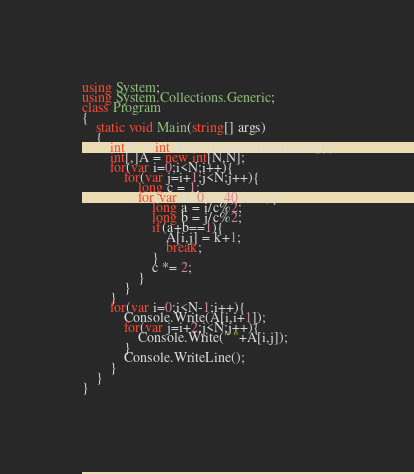Convert code to text. <code><loc_0><loc_0><loc_500><loc_500><_C#_>using System;
using System.Collections.Generic;
class Program
{
	static void Main(string[] args)
	{
		int N = int.Parse(Console.ReadLine());
		int[,]A = new int[N,N];
		for(var i=0;i<N;i++){
			for(var j=i+1;j<N;j++){
				long c = 1;
				for(var k=0;k<40;k++){
					long a = i/c%2;
					long b = j/c%2;
					if(a+b==1){
						A[i,j] = k+1;
						break;
					}
					c *= 2;
				}
			}
		}
		for(var i=0;i<N-1;i++){
			Console.Write(A[i,i+1]);
			for(var j=i+2;j<N;j++){
				Console.Write(" "+A[i,j]);
			}
			Console.WriteLine();
		}
	}
}</code> 